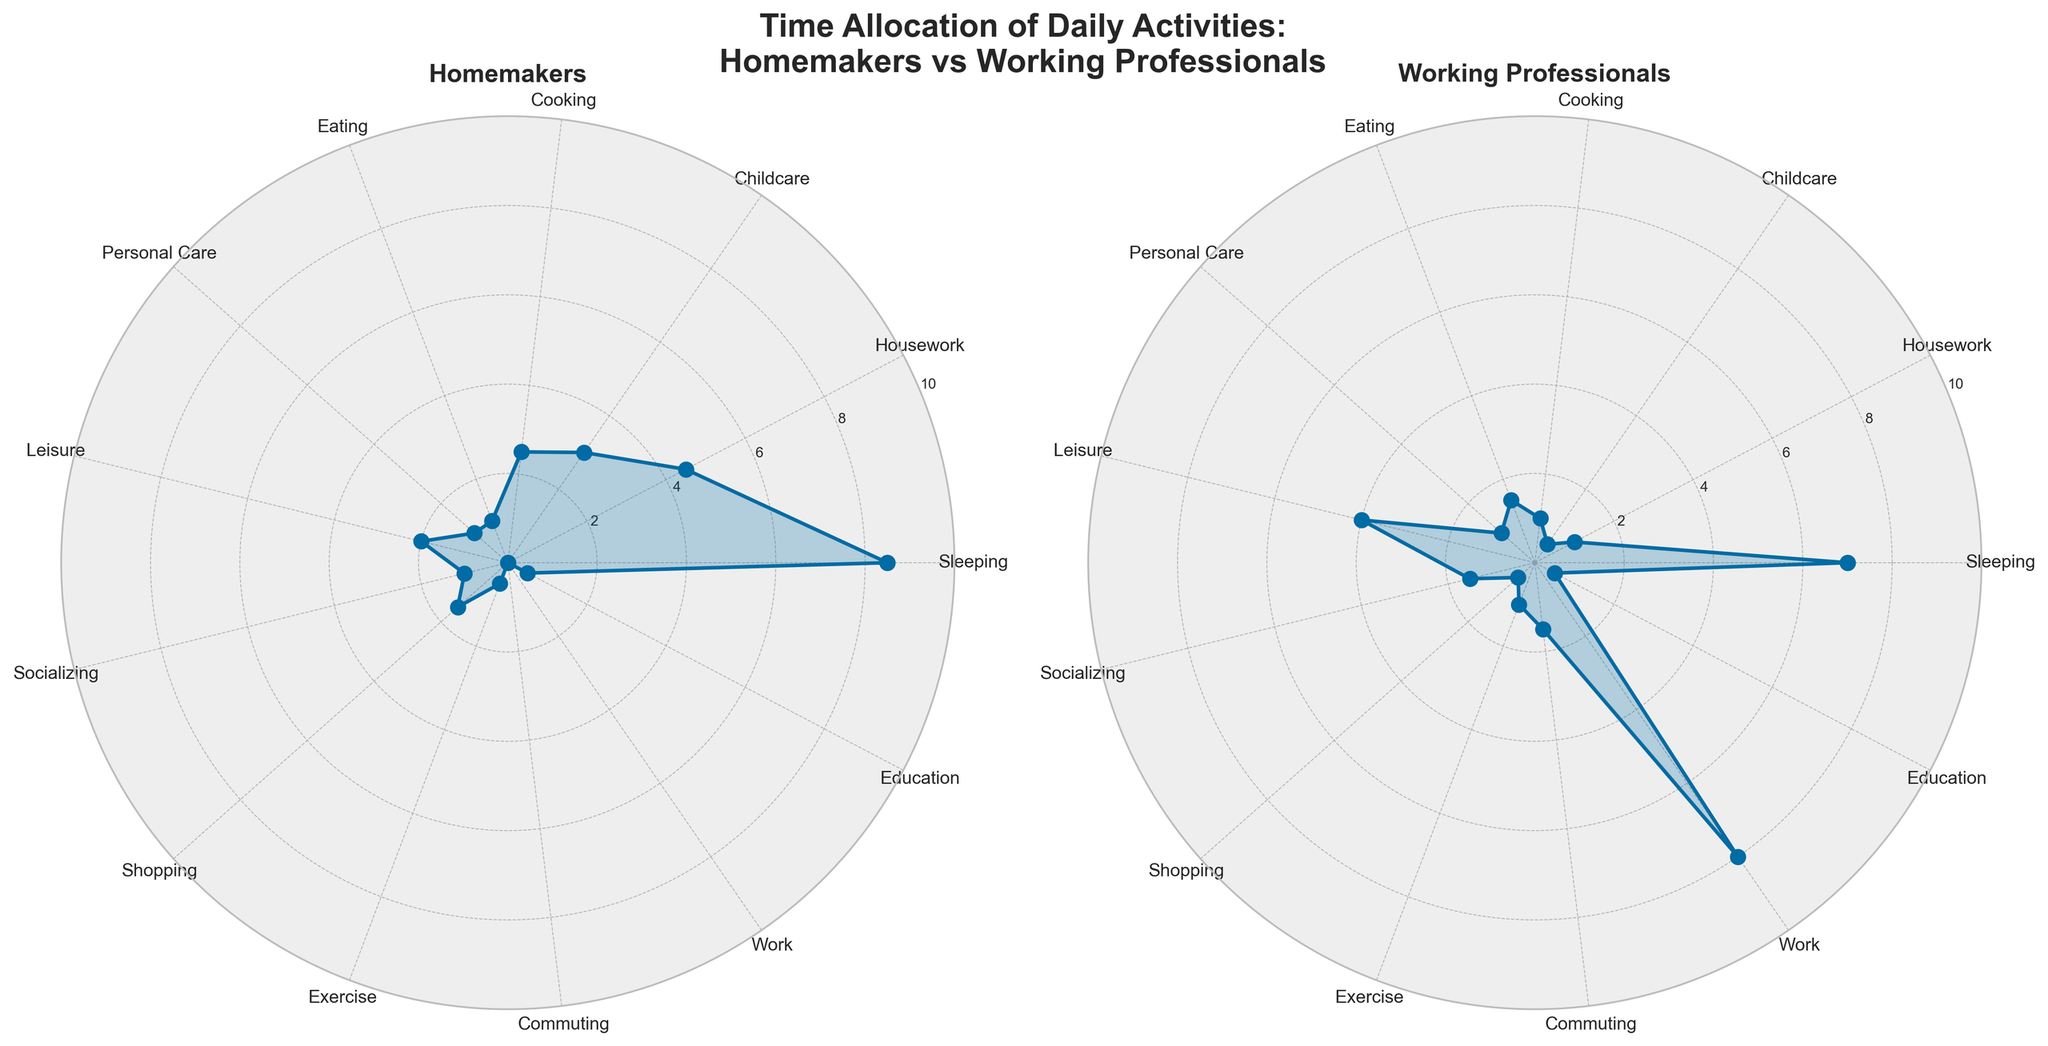What is the title of the figure? The title of the figure is located at the top center and states the overall theme of the plots.
Answer: Time Allocation of Daily Activities: Homemakers vs Working Professionals Which group spends more time on leisure activities? By examining the leisure section in both radar charts, we can see that the time for leisure is higher in the working professionals plot (4 hours) compared to the homemakers plot (2 hours).
Answer: Working Professionals How much time do homemakers spend on cooking compared to working professionals? By comparing the cooking section in each radar chart, homemakers spend 2.5 hours, whereas working professionals spend 1 hour.
Answer: Homemakers spend 1.5 hours more What is the combined time spent on eating and socializing for homemakers? For homemakers, the time spent on eating is 1 hour and on socializing is also 1 hour. Summing these times gives 1 + 1 = 2 hours.
Answer: 2 hours Who allocates more hours to work-related activities? On the working professionals' radar chart, work-related activities (work and commuting) sum up to 9.5 hours. Homemakers do not have any time allocated to work or commuting.
Answer: Working Professionals Which group spends less time sleeping, and by how much? The radar chart shows that homemakers spend 8.5 hours sleeping while working professionals spend 7 hours. By subtracting 7 from 8.5, we find that working professionals spend 1.5 hours less sleeping.
Answer: Working Professionals, by 1.5 hours What is the difference in childcare time between the two groups? The radar chart indicates homemakers spend 3 hours on childcare, while working professionals spend 0.5 hours. The difference is 3 - 0.5 = 2.5 hours.
Answer: 2.5 hours How many categories show identical time allocation between homemakers and working professionals? By examining the data, the categories where the time allocation is the same are: Personal Care and Education. Therefore, there are 2 categories with identical time allocation.
Answer: 2 categories What is the average time spent by homemakers on house-related activities? House-related activities for homemakers include housework (4.5), cooking (2.5), childcare (3), and shopping (1.5). The average is calculated as (4.5 + 2.5 + 3 + 1.5) / 4 = 2.875 hours.
Answer: 2.88 hours Which group spends more time on personal care and by how much? The radar chart shows that both homemakers and working professionals spend equal time of 1 hour on personal care.
Answer: Both groups spend the same amount of time 